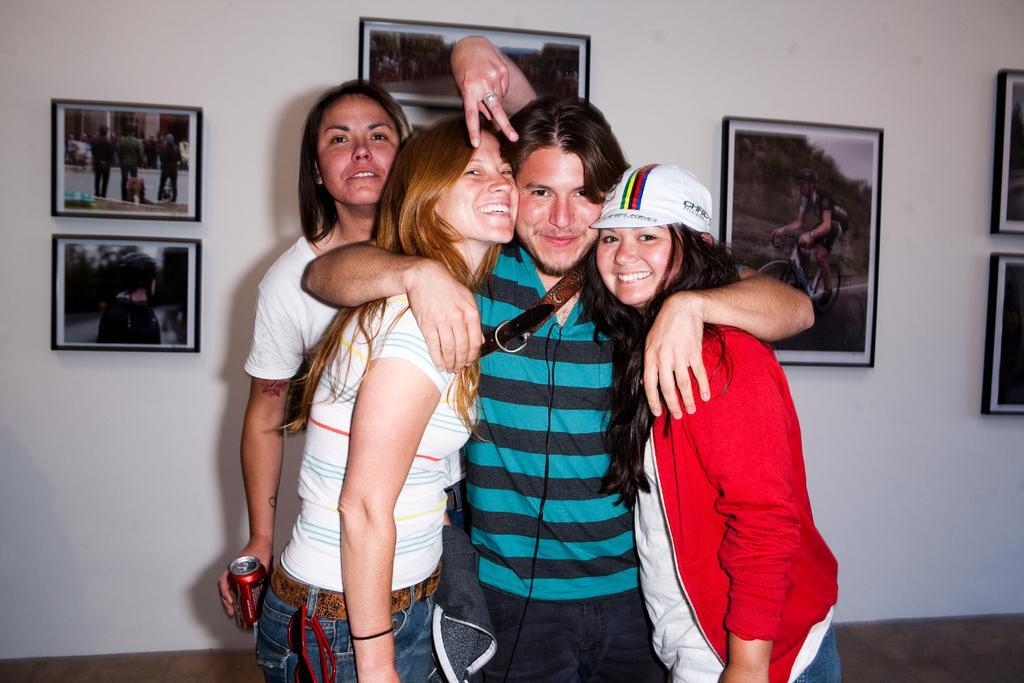Can you describe this image briefly? In the picture we can see three girls and one man is standing together and they are smiling and one girl is holding a coke tin in the hand, which is red in color and behind them, we can see a wall with some photo frames in it and on it we can see some images. 